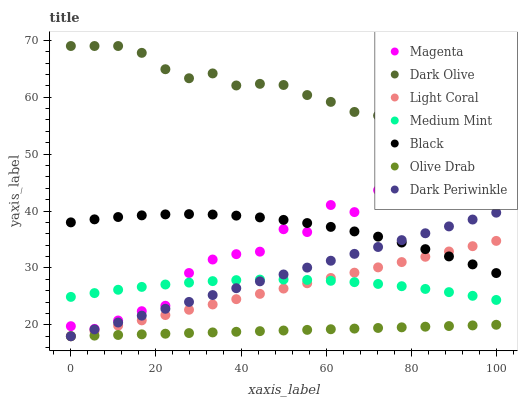Does Olive Drab have the minimum area under the curve?
Answer yes or no. Yes. Does Dark Olive have the maximum area under the curve?
Answer yes or no. Yes. Does Light Coral have the minimum area under the curve?
Answer yes or no. No. Does Light Coral have the maximum area under the curve?
Answer yes or no. No. Is Olive Drab the smoothest?
Answer yes or no. Yes. Is Magenta the roughest?
Answer yes or no. Yes. Is Dark Olive the smoothest?
Answer yes or no. No. Is Dark Olive the roughest?
Answer yes or no. No. Does Light Coral have the lowest value?
Answer yes or no. Yes. Does Dark Olive have the lowest value?
Answer yes or no. No. Does Dark Olive have the highest value?
Answer yes or no. Yes. Does Light Coral have the highest value?
Answer yes or no. No. Is Dark Periwinkle less than Dark Olive?
Answer yes or no. Yes. Is Black greater than Medium Mint?
Answer yes or no. Yes. Does Dark Periwinkle intersect Light Coral?
Answer yes or no. Yes. Is Dark Periwinkle less than Light Coral?
Answer yes or no. No. Is Dark Periwinkle greater than Light Coral?
Answer yes or no. No. Does Dark Periwinkle intersect Dark Olive?
Answer yes or no. No. 